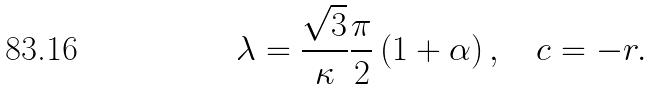Convert formula to latex. <formula><loc_0><loc_0><loc_500><loc_500>\lambda = \frac { \sqrt { 3 } } { \kappa } \frac { \pi } { 2 } \left ( 1 + \alpha \right ) , \quad c = - r .</formula> 